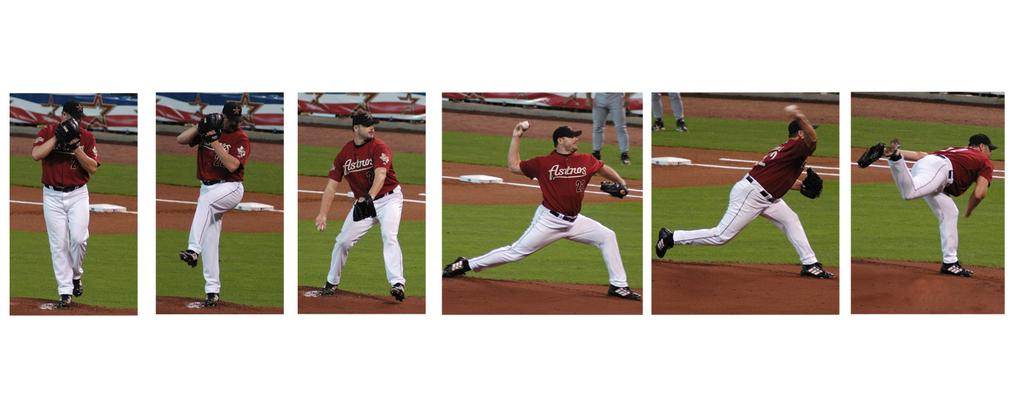<image>
Render a clear and concise summary of the photo. A man in an Astros jersey is pitching a baseball. 